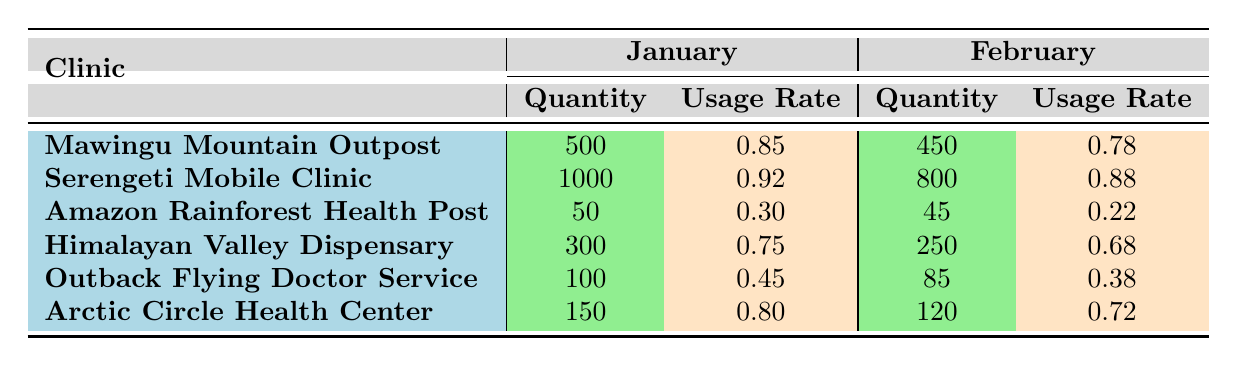What is the quantity of Antibiotics available in Mawingu Mountain Outpost in January? The table shows that the quantity of Antibiotics available in Mawingu Mountain Outpost in January is listed directly. Looking at the row for Mawingu Mountain Outpost under January, the quantity is recorded as 500.
Answer: 500 Which clinic used the most quantity of Oral Rehydration Salts in February? By examining the February data, we see that Serengeti Mobile Clinic has a quantity of 800 Oral Rehydration Salts, which is higher than any other clinic in this month as no other clinics have this item in that month.
Answer: Serengeti Mobile Clinic Did the usage rate of Antivenoms in Amazon Rainforest Health Post decrease from January to February? The usage rates are listed in the table for both months. In January, the usage rate of Antivenoms is 0.30, and in February, it is 0.22. Since 0.22 is less than 0.30, the usage rate indeed decreased.
Answer: Yes What is the total quantity of Frostbite Treatment Supplies for Arctic Circle Health Center across both months? To find the total quantity across both months for Arctic Circle Health Center, we add the quantities from January (150) and February (120). Therefore, 150 + 120 equals 270.
Answer: 270 Which clinic had the lowest usage rate for any item in February? We need to look at the usage rates for each clinic in February. The Amazon Rainforest Health Post shows a usage rate of 0.22 for Antivenoms, which is the lowest across all clinics listed for February.
Answer: Amazon Rainforest Health Post 